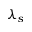Convert formula to latex. <formula><loc_0><loc_0><loc_500><loc_500>\lambda _ { s }</formula> 